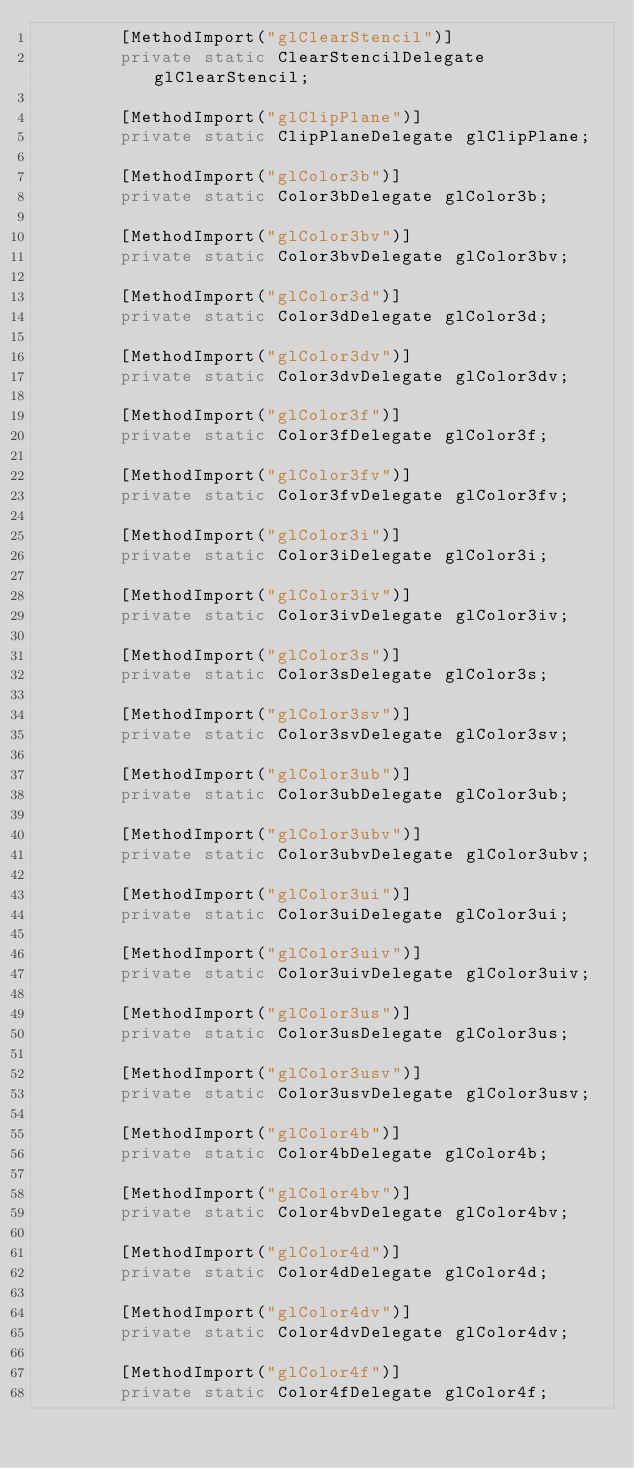Convert code to text. <code><loc_0><loc_0><loc_500><loc_500><_C#_>		[MethodImport("glClearStencil")]
		private static ClearStencilDelegate glClearStencil;

		[MethodImport("glClipPlane")]
		private static ClipPlaneDelegate glClipPlane;

		[MethodImport("glColor3b")]
		private static Color3bDelegate glColor3b;

		[MethodImport("glColor3bv")]
		private static Color3bvDelegate glColor3bv;

		[MethodImport("glColor3d")]
		private static Color3dDelegate glColor3d;

		[MethodImport("glColor3dv")]
		private static Color3dvDelegate glColor3dv;

		[MethodImport("glColor3f")]
		private static Color3fDelegate glColor3f;

		[MethodImport("glColor3fv")]
		private static Color3fvDelegate glColor3fv;

		[MethodImport("glColor3i")]
		private static Color3iDelegate glColor3i;

		[MethodImport("glColor3iv")]
		private static Color3ivDelegate glColor3iv;

		[MethodImport("glColor3s")]
		private static Color3sDelegate glColor3s;

		[MethodImport("glColor3sv")]
		private static Color3svDelegate glColor3sv;

		[MethodImport("glColor3ub")]
		private static Color3ubDelegate glColor3ub;

		[MethodImport("glColor3ubv")]
		private static Color3ubvDelegate glColor3ubv;

		[MethodImport("glColor3ui")]
		private static Color3uiDelegate glColor3ui;

		[MethodImport("glColor3uiv")]
		private static Color3uivDelegate glColor3uiv;

		[MethodImport("glColor3us")]
		private static Color3usDelegate glColor3us;

		[MethodImport("glColor3usv")]
		private static Color3usvDelegate glColor3usv;

		[MethodImport("glColor4b")]
		private static Color4bDelegate glColor4b;

		[MethodImport("glColor4bv")]
		private static Color4bvDelegate glColor4bv;

		[MethodImport("glColor4d")]
		private static Color4dDelegate glColor4d;

		[MethodImport("glColor4dv")]
		private static Color4dvDelegate glColor4dv;

		[MethodImport("glColor4f")]
		private static Color4fDelegate glColor4f;
</code> 